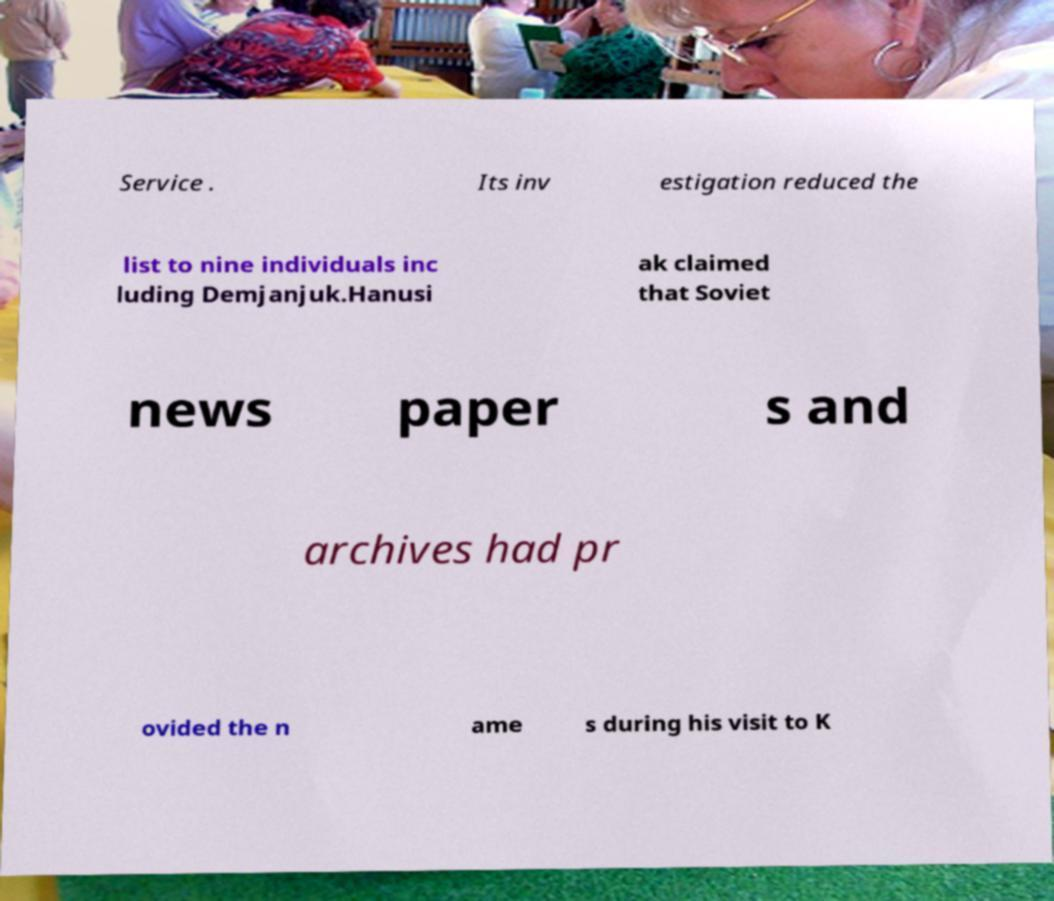Please identify and transcribe the text found in this image. Service . Its inv estigation reduced the list to nine individuals inc luding Demjanjuk.Hanusi ak claimed that Soviet news paper s and archives had pr ovided the n ame s during his visit to K 